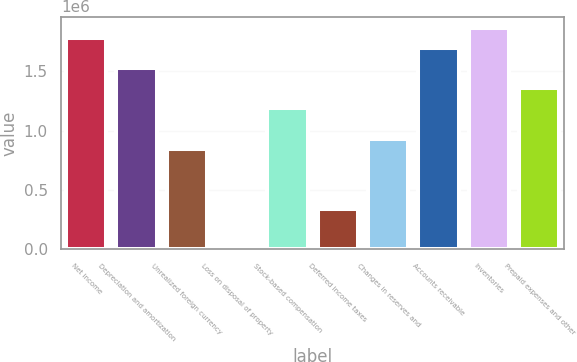Convert chart to OTSL. <chart><loc_0><loc_0><loc_500><loc_500><bar_chart><fcel>Net income<fcel>Depreciation and amortization<fcel>Unrealized foreign currency<fcel>Loss on disposal of property<fcel>Stock-based compensation<fcel>Deferred income taxes<fcel>Changes in reserves and<fcel>Accounts receivable<fcel>Inventories<fcel>Prepaid expenses and other<nl><fcel>1.77909e+06<fcel>1.52502e+06<fcel>847475<fcel>549<fcel>1.18625e+06<fcel>339319<fcel>932168<fcel>1.6944e+06<fcel>1.86379e+06<fcel>1.35563e+06<nl></chart> 